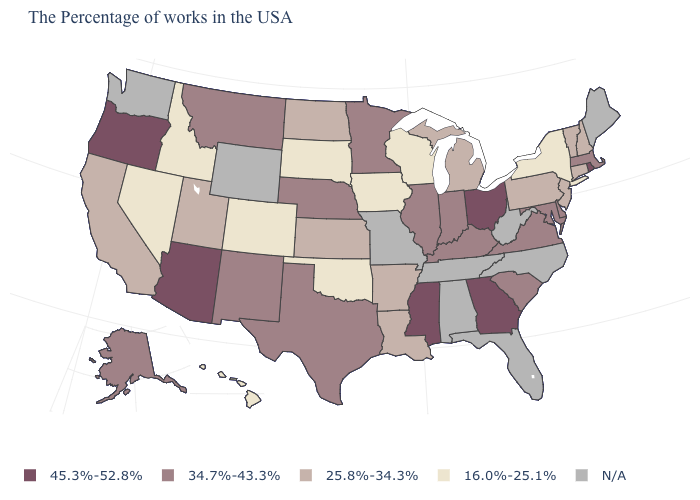What is the highest value in the Northeast ?
Keep it brief. 45.3%-52.8%. What is the value of Indiana?
Be succinct. 34.7%-43.3%. What is the value of Connecticut?
Short answer required. 25.8%-34.3%. Is the legend a continuous bar?
Give a very brief answer. No. What is the value of New Mexico?
Short answer required. 34.7%-43.3%. Does Massachusetts have the lowest value in the USA?
Short answer required. No. What is the highest value in the Northeast ?
Write a very short answer. 45.3%-52.8%. What is the highest value in the USA?
Concise answer only. 45.3%-52.8%. Among the states that border Massachusetts , which have the lowest value?
Give a very brief answer. New York. Name the states that have a value in the range 16.0%-25.1%?
Quick response, please. New York, Wisconsin, Iowa, Oklahoma, South Dakota, Colorado, Idaho, Nevada, Hawaii. What is the value of New York?
Write a very short answer. 16.0%-25.1%. Does South Dakota have the lowest value in the USA?
Write a very short answer. Yes. Name the states that have a value in the range 45.3%-52.8%?
Write a very short answer. Rhode Island, Ohio, Georgia, Mississippi, Arizona, Oregon. Which states have the lowest value in the MidWest?
Be succinct. Wisconsin, Iowa, South Dakota. 